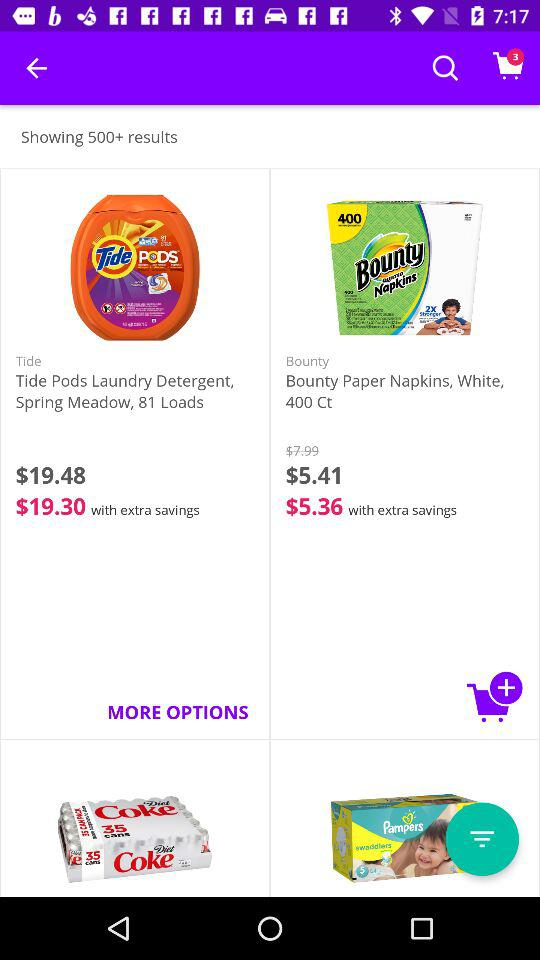What is the price of "Bounty Paper Napkins" before the discount? The price is $7.99. 